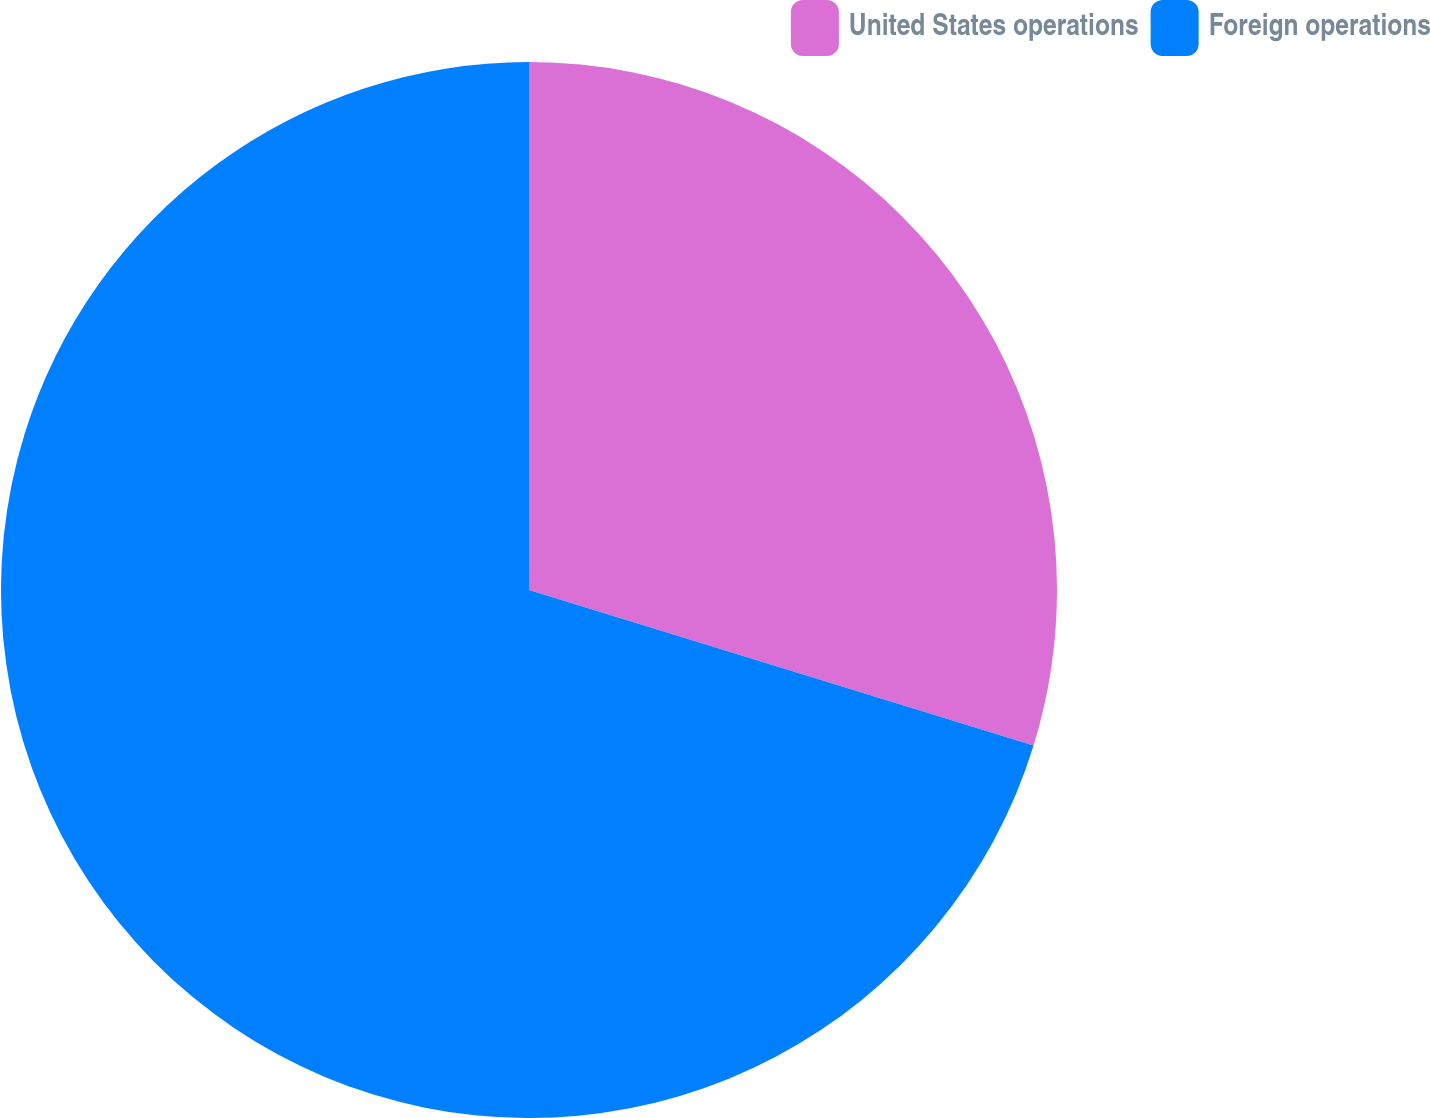Convert chart. <chart><loc_0><loc_0><loc_500><loc_500><pie_chart><fcel>United States operations<fcel>Foreign operations<nl><fcel>29.76%<fcel>70.24%<nl></chart> 